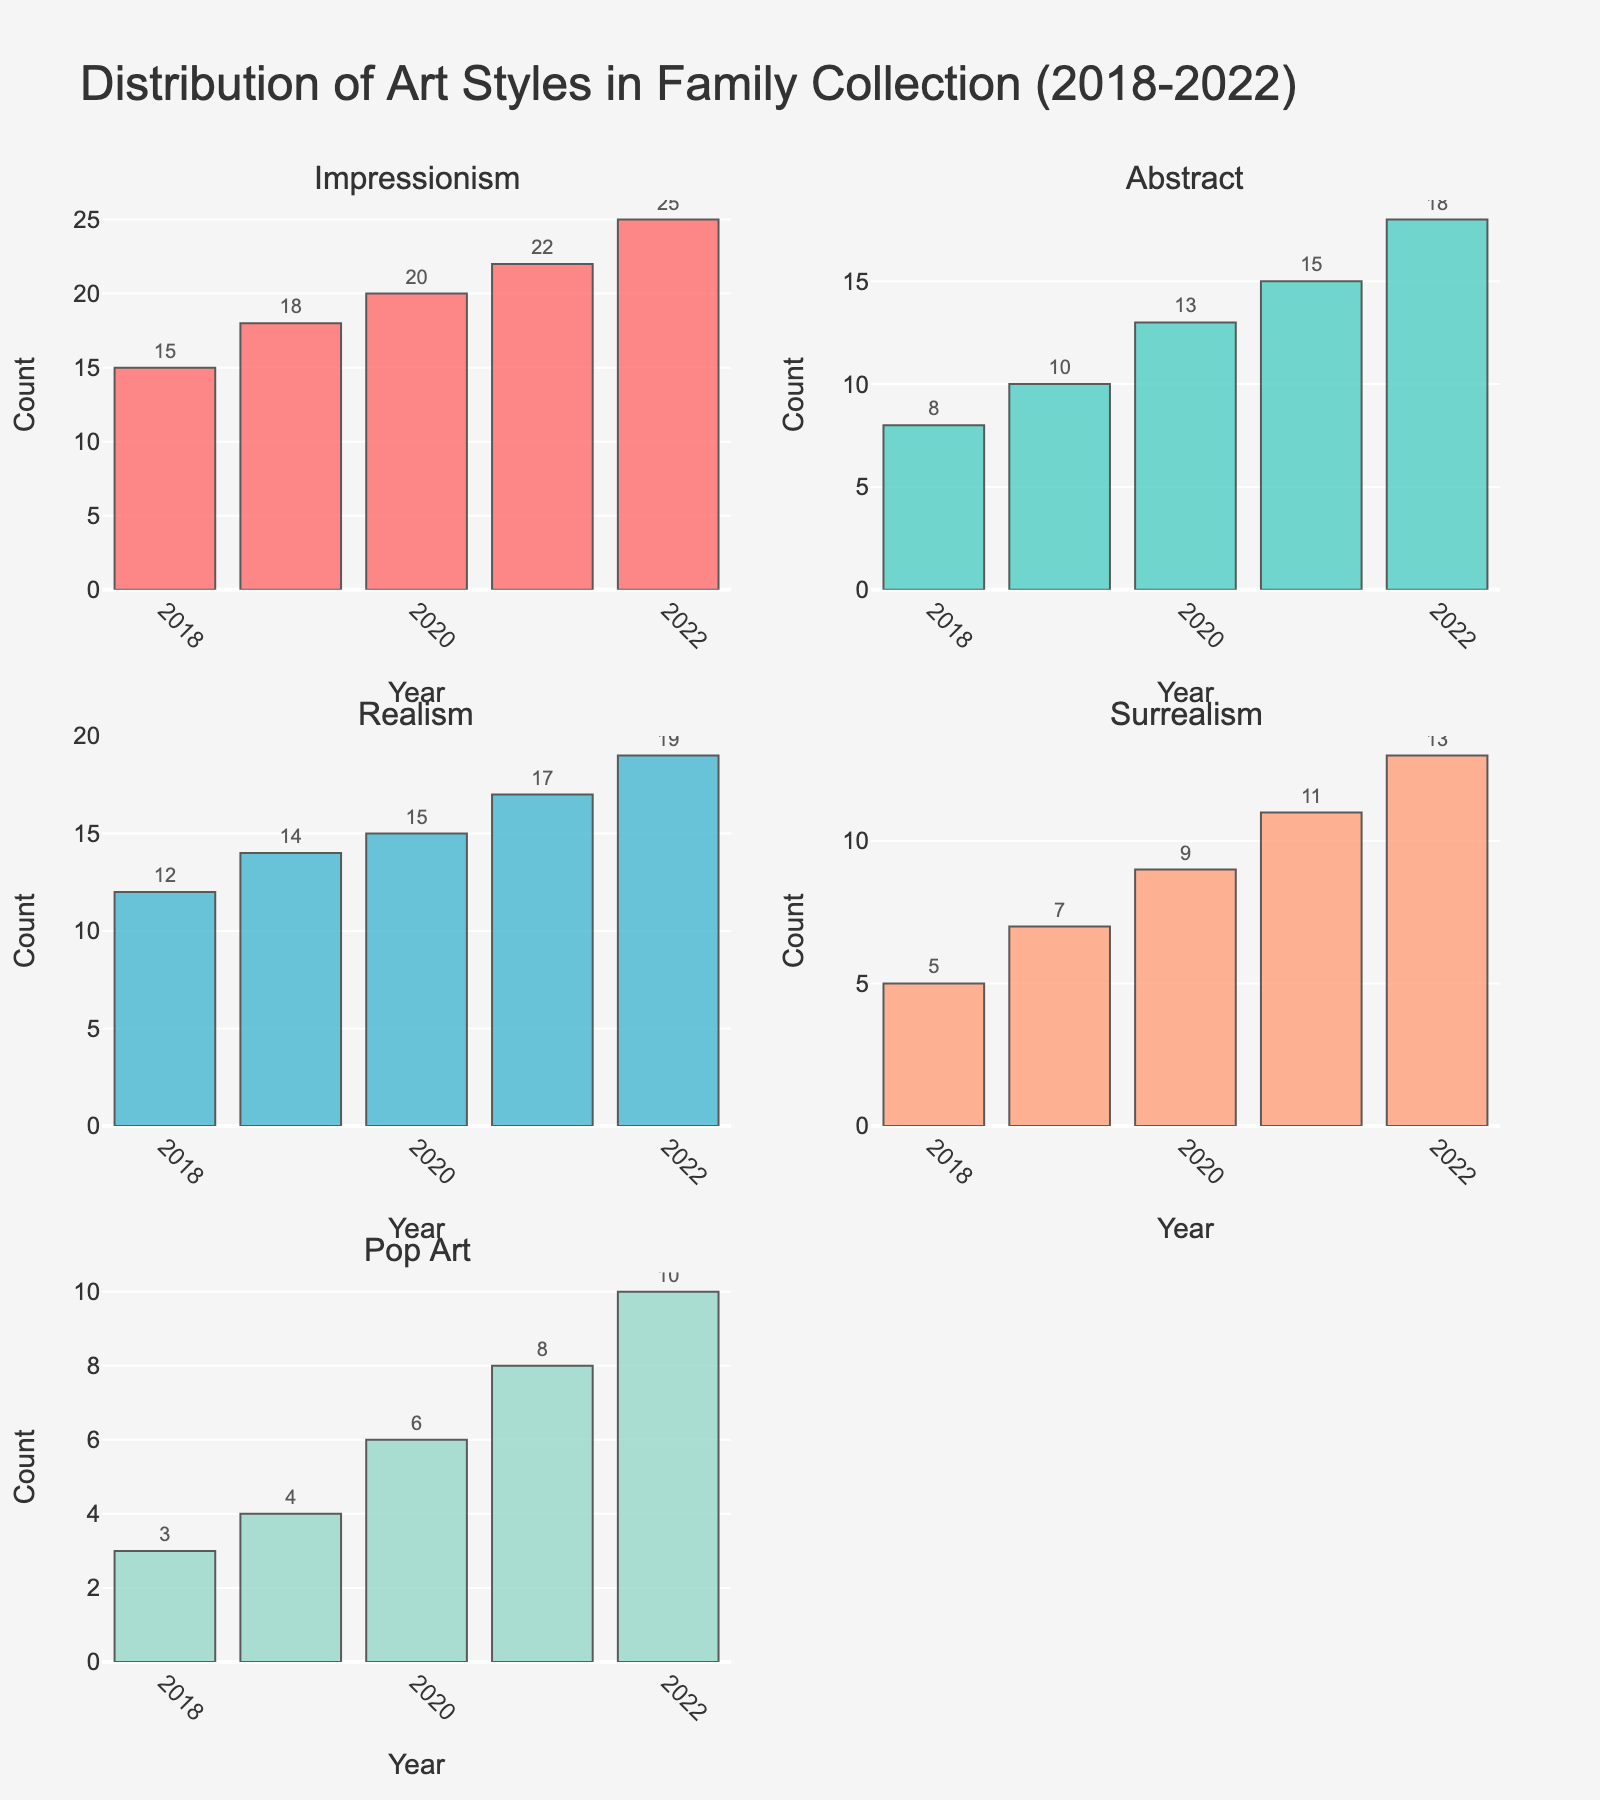what's the title of the figure? The title of the figure is located at the top and is displayed in a larger font size compared to other text elements. It summarizes the content of the figure in a concise manner.
Answer: Distribution of Art Styles in Family Collection (2018-2022) what are the colors used for each art style? Each art style is represented by a distinct color. These colors are used to differentiate between the different categories in the bar charts.
Answer: Impressionism: #FF6B6B (red), Abstract: #4ECDC4 (teal), Realism: #45B7D1 (blue), Surrealism: #FFA07A (salmon), Pop Art: #98D8C8 (mint) how many data points are there for each art style? There are five years of data present in the figure, each represented as a separate bar for each art style. Thus, for each art style, there are five data points.
Answer: 5 which year saw the highest count of Impressionism? Look at the bars corresponding to 'Impressionism' and find the tallest one. The year associated with this bar will have the highest count.
Answer: 2022 what is the total count of Realism from 2018 to 2022? To find the total, sum up the counts of Realism for all the years: 12 (2018) + 14 (2019) + 15 (2020) + 17 (2021) + 19 (2022).
Answer: 77 which art style saw the greatest increase in count from 2018 to 2022? Calculate the difference between the counts for 2018 and 2022 for each art style: Impressionism (25-15), Abstract (18-8), Realism (19-12), Surrealism (13-5), Pop Art (10-3). Then identify the largest difference.
Answer: Impressionism (10) in which year was the count of Abstract art equal to the count of Surrealism the previous year? Compare the counts of Abstract art for each year with the Surrealism counts of the previous year. Abstract in 2019 (10) matches Surrealism in 2018 (5+2=7).
Answer: 2019 how does the growth trend of Pop Art compare to that of Surrealism? Observe the bar heights for Pop Art and Surrealism from 2018 to 2022 individually and note their patterns. You'll see that both art styles are increasing, but Pop Art starts from a lower baseline and grows slower.
Answer: Pop Art grows slower than Surrealism what is the average count of Surrealism over the five years? Sum the counts of Surrealism from 2018 to 2022 and divide by 5: (5 + 7 + 9 + 11 + 13) / 5.
Answer: 9 how many more pieces of Impressionism are in the collection in 2022 compared to 2018? Subtract the count of Impressionism in 2018 from the count in 2022: 25 - 15.
Answer: 10 